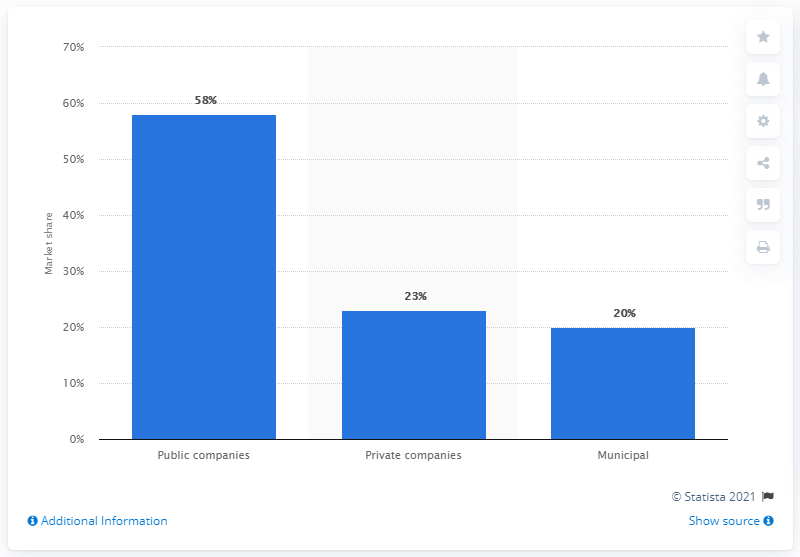Indicate a few pertinent items in this graphic. According to the waste management industry's financial reports, publicly traded companies accounted for approximately 58% of their total revenues. 